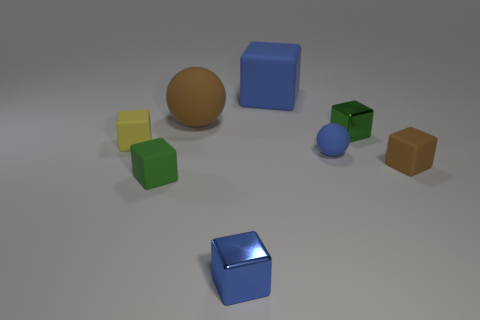Add 1 green rubber objects. How many objects exist? 9 Subtract all yellow matte blocks. How many blocks are left? 5 Subtract all spheres. How many objects are left? 6 Subtract all blue balls. How many balls are left? 1 Subtract 0 cyan balls. How many objects are left? 8 Subtract 5 blocks. How many blocks are left? 1 Subtract all gray cubes. Subtract all red cylinders. How many cubes are left? 6 Subtract all yellow balls. How many blue blocks are left? 2 Subtract all large blue shiny things. Subtract all blue matte things. How many objects are left? 6 Add 7 large brown rubber balls. How many large brown rubber balls are left? 8 